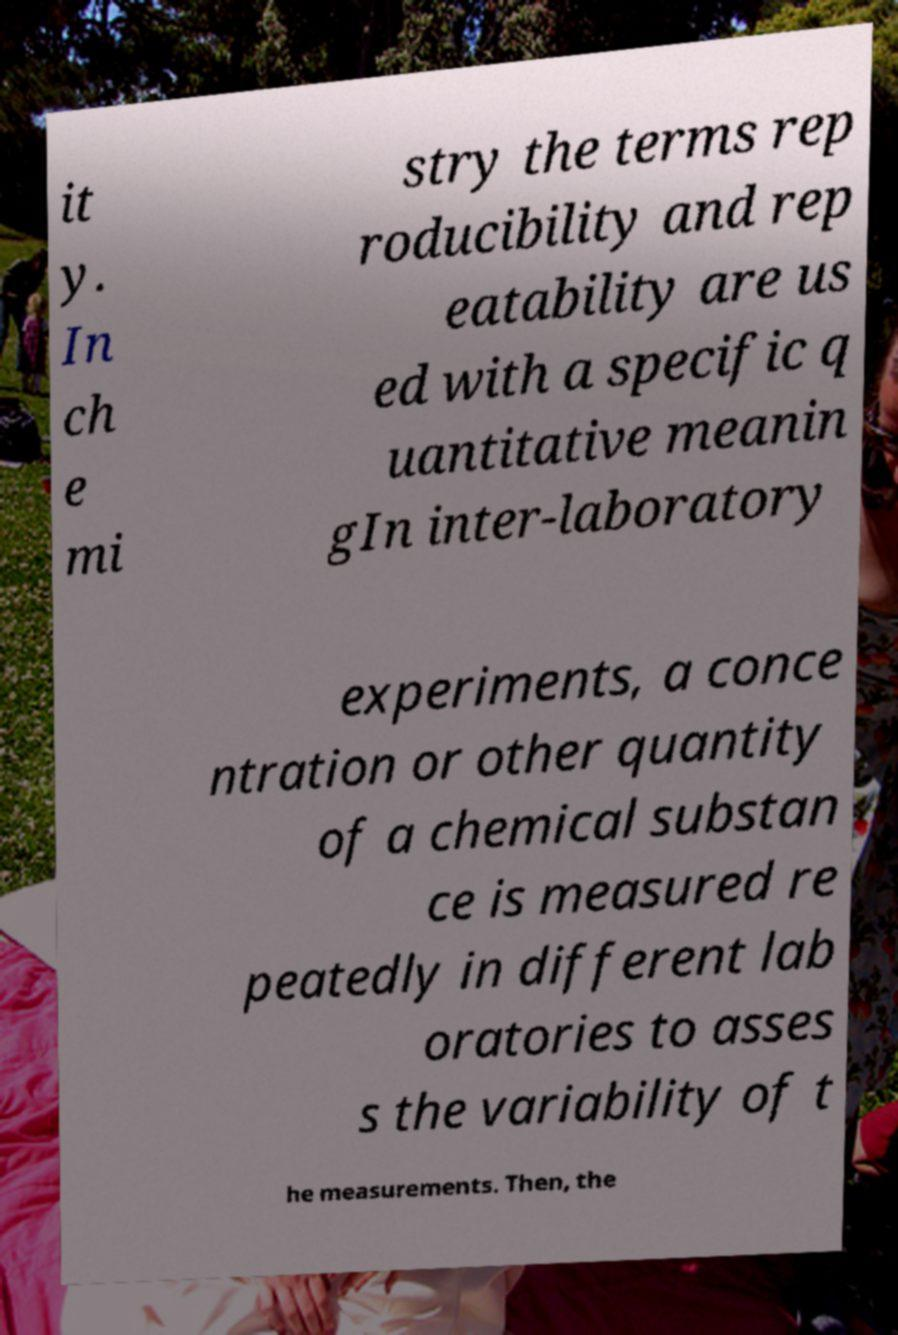Could you extract and type out the text from this image? it y. In ch e mi stry the terms rep roducibility and rep eatability are us ed with a specific q uantitative meanin gIn inter-laboratory experiments, a conce ntration or other quantity of a chemical substan ce is measured re peatedly in different lab oratories to asses s the variability of t he measurements. Then, the 